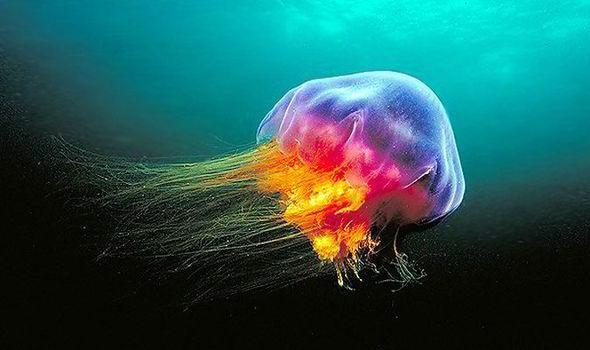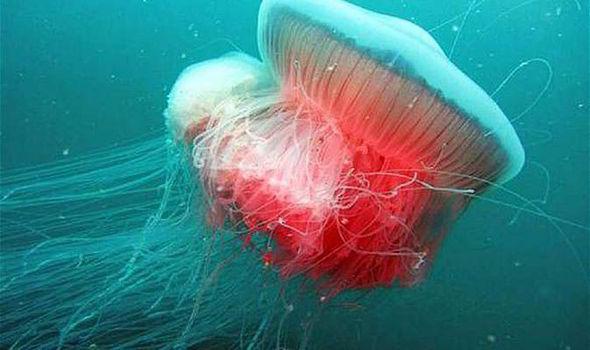The first image is the image on the left, the second image is the image on the right. Assess this claim about the two images: "One scuba diver is to the right of a jelly fish.". Correct or not? Answer yes or no. No. The first image is the image on the left, the second image is the image on the right. Examine the images to the left and right. Is the description "The left image contains one human scuba diving." accurate? Answer yes or no. No. 